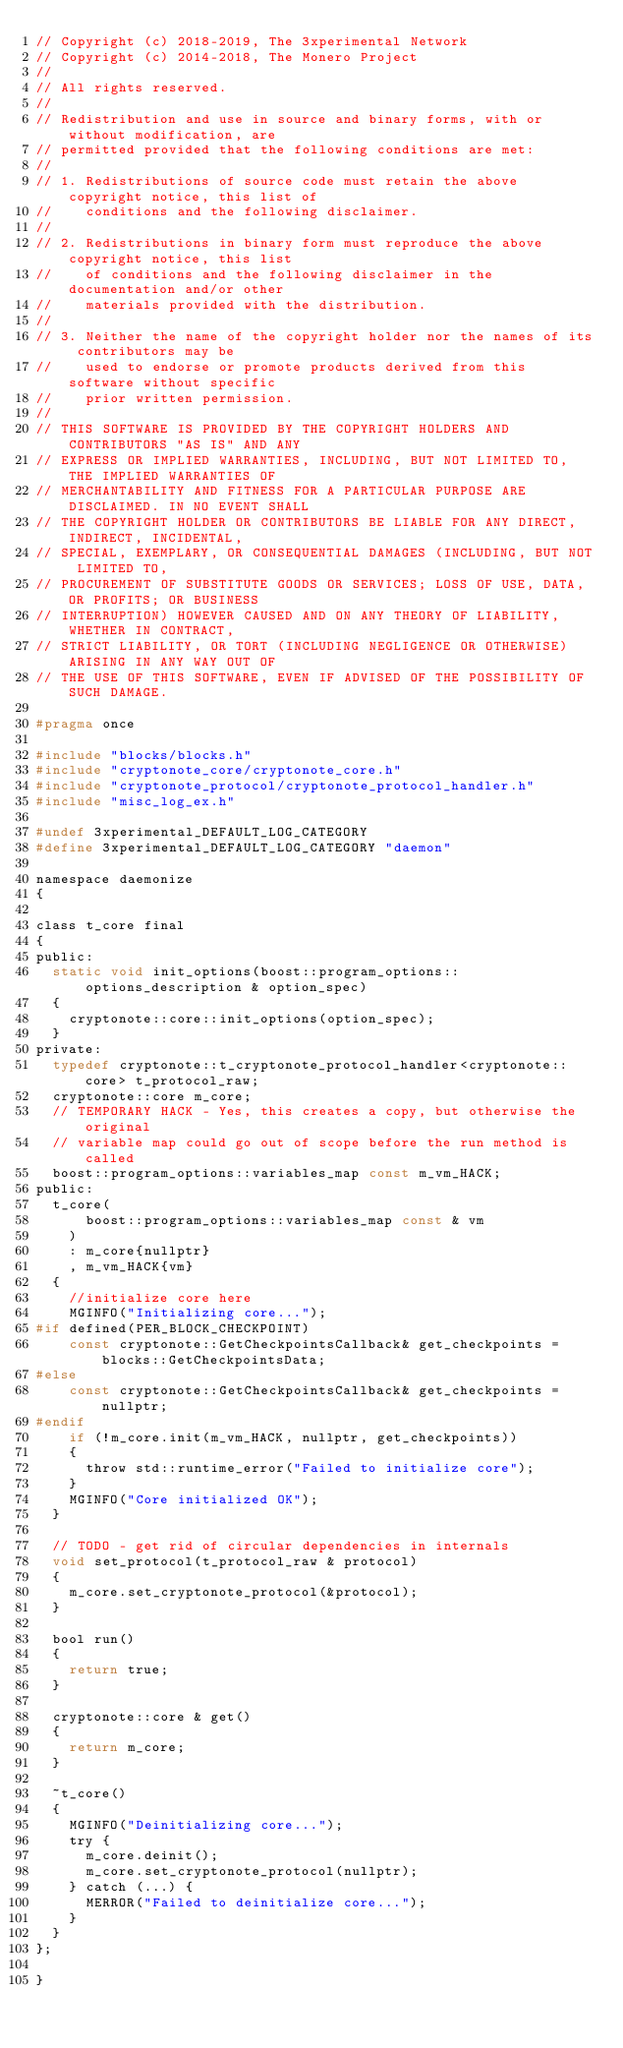<code> <loc_0><loc_0><loc_500><loc_500><_C_>// Copyright (c) 2018-2019, The 3xperimental Network
// Copyright (c) 2014-2018, The Monero Project
//
// All rights reserved.
//
// Redistribution and use in source and binary forms, with or without modification, are
// permitted provided that the following conditions are met:
//
// 1. Redistributions of source code must retain the above copyright notice, this list of
//    conditions and the following disclaimer.
//
// 2. Redistributions in binary form must reproduce the above copyright notice, this list
//    of conditions and the following disclaimer in the documentation and/or other
//    materials provided with the distribution.
//
// 3. Neither the name of the copyright holder nor the names of its contributors may be
//    used to endorse or promote products derived from this software without specific
//    prior written permission.
//
// THIS SOFTWARE IS PROVIDED BY THE COPYRIGHT HOLDERS AND CONTRIBUTORS "AS IS" AND ANY
// EXPRESS OR IMPLIED WARRANTIES, INCLUDING, BUT NOT LIMITED TO, THE IMPLIED WARRANTIES OF
// MERCHANTABILITY AND FITNESS FOR A PARTICULAR PURPOSE ARE DISCLAIMED. IN NO EVENT SHALL
// THE COPYRIGHT HOLDER OR CONTRIBUTORS BE LIABLE FOR ANY DIRECT, INDIRECT, INCIDENTAL,
// SPECIAL, EXEMPLARY, OR CONSEQUENTIAL DAMAGES (INCLUDING, BUT NOT LIMITED TO,
// PROCUREMENT OF SUBSTITUTE GOODS OR SERVICES; LOSS OF USE, DATA, OR PROFITS; OR BUSINESS
// INTERRUPTION) HOWEVER CAUSED AND ON ANY THEORY OF LIABILITY, WHETHER IN CONTRACT,
// STRICT LIABILITY, OR TORT (INCLUDING NEGLIGENCE OR OTHERWISE) ARISING IN ANY WAY OUT OF
// THE USE OF THIS SOFTWARE, EVEN IF ADVISED OF THE POSSIBILITY OF SUCH DAMAGE.

#pragma once

#include "blocks/blocks.h"
#include "cryptonote_core/cryptonote_core.h"
#include "cryptonote_protocol/cryptonote_protocol_handler.h"
#include "misc_log_ex.h"

#undef 3xperimental_DEFAULT_LOG_CATEGORY
#define 3xperimental_DEFAULT_LOG_CATEGORY "daemon"

namespace daemonize
{

class t_core final
{
public:
  static void init_options(boost::program_options::options_description & option_spec)
  {
    cryptonote::core::init_options(option_spec);
  }
private:
  typedef cryptonote::t_cryptonote_protocol_handler<cryptonote::core> t_protocol_raw;
  cryptonote::core m_core;
  // TEMPORARY HACK - Yes, this creates a copy, but otherwise the original
  // variable map could go out of scope before the run method is called
  boost::program_options::variables_map const m_vm_HACK;
public:
  t_core(
      boost::program_options::variables_map const & vm
    )
    : m_core{nullptr}
    , m_vm_HACK{vm}
  {
    //initialize core here
    MGINFO("Initializing core...");
#if defined(PER_BLOCK_CHECKPOINT)
    const cryptonote::GetCheckpointsCallback& get_checkpoints = blocks::GetCheckpointsData;
#else
    const cryptonote::GetCheckpointsCallback& get_checkpoints = nullptr;
#endif
    if (!m_core.init(m_vm_HACK, nullptr, get_checkpoints))
    {
      throw std::runtime_error("Failed to initialize core");
    }
    MGINFO("Core initialized OK");
  }

  // TODO - get rid of circular dependencies in internals
  void set_protocol(t_protocol_raw & protocol)
  {
    m_core.set_cryptonote_protocol(&protocol);
  }

  bool run()
  {
    return true;
  }

  cryptonote::core & get()
  {
    return m_core;
  }

  ~t_core()
  {
    MGINFO("Deinitializing core...");
    try {
      m_core.deinit();
      m_core.set_cryptonote_protocol(nullptr);
    } catch (...) {
      MERROR("Failed to deinitialize core...");
    }
  }
};

}
</code> 